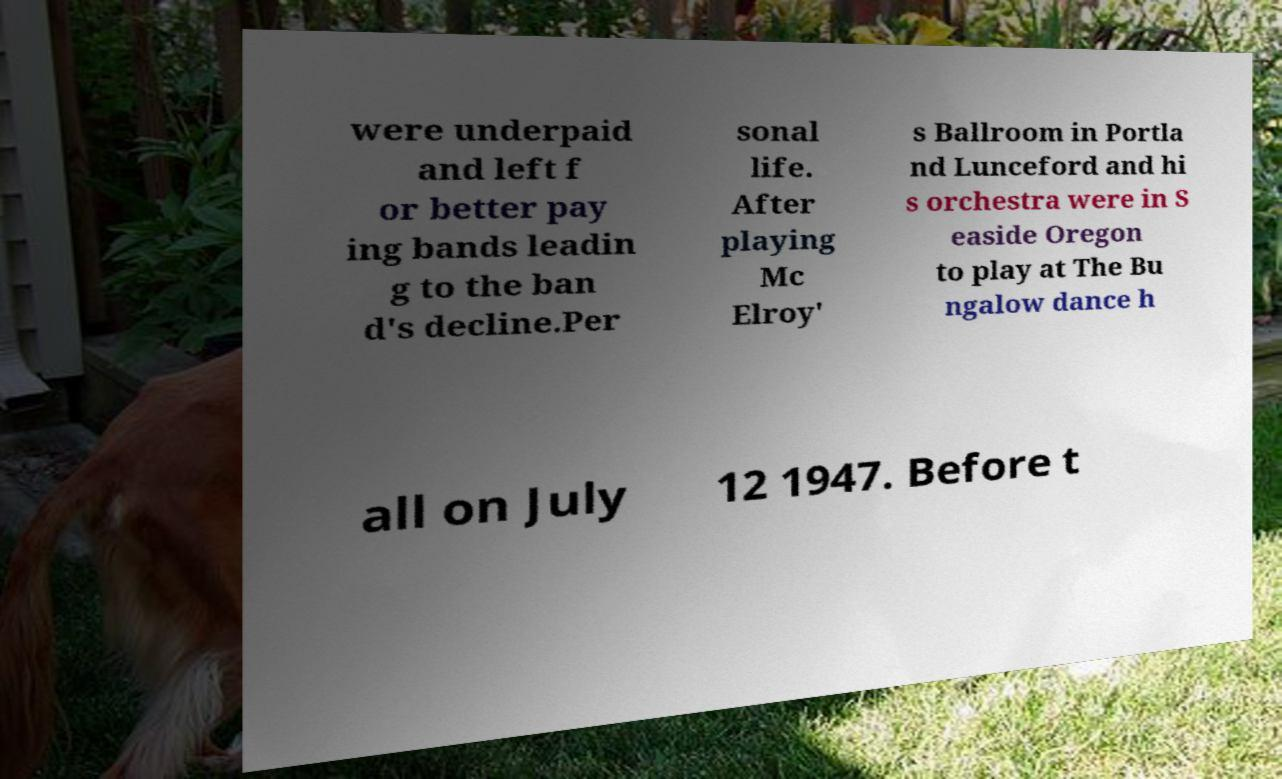There's text embedded in this image that I need extracted. Can you transcribe it verbatim? were underpaid and left f or better pay ing bands leadin g to the ban d's decline.Per sonal life. After playing Mc Elroy' s Ballroom in Portla nd Lunceford and hi s orchestra were in S easide Oregon to play at The Bu ngalow dance h all on July 12 1947. Before t 